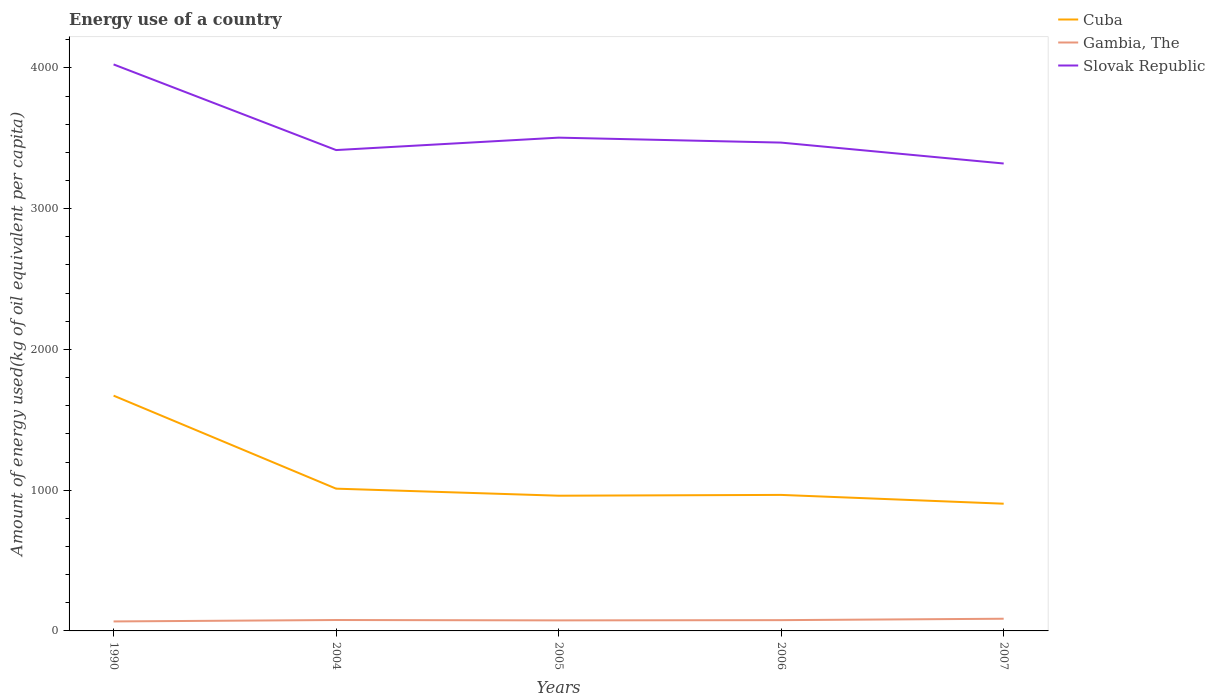How many different coloured lines are there?
Provide a succinct answer. 3. Across all years, what is the maximum amount of energy used in in Cuba?
Offer a terse response. 903.8. In which year was the amount of energy used in in Slovak Republic maximum?
Ensure brevity in your answer.  2007. What is the total amount of energy used in in Cuba in the graph?
Your answer should be very brief. 710.84. What is the difference between the highest and the second highest amount of energy used in in Gambia, The?
Offer a very short reply. 19.17. Is the amount of energy used in in Cuba strictly greater than the amount of energy used in in Gambia, The over the years?
Your answer should be compact. No. How many years are there in the graph?
Your response must be concise. 5. Are the values on the major ticks of Y-axis written in scientific E-notation?
Provide a short and direct response. No. Does the graph contain any zero values?
Ensure brevity in your answer.  No. How many legend labels are there?
Keep it short and to the point. 3. How are the legend labels stacked?
Offer a terse response. Vertical. What is the title of the graph?
Provide a succinct answer. Energy use of a country. Does "Palau" appear as one of the legend labels in the graph?
Keep it short and to the point. No. What is the label or title of the Y-axis?
Give a very brief answer. Amount of energy used(kg of oil equivalent per capita). What is the Amount of energy used(kg of oil equivalent per capita) in Cuba in 1990?
Provide a short and direct response. 1671.51. What is the Amount of energy used(kg of oil equivalent per capita) of Gambia, The in 1990?
Keep it short and to the point. 67.4. What is the Amount of energy used(kg of oil equivalent per capita) in Slovak Republic in 1990?
Provide a short and direct response. 4024.67. What is the Amount of energy used(kg of oil equivalent per capita) of Cuba in 2004?
Your answer should be very brief. 1010.68. What is the Amount of energy used(kg of oil equivalent per capita) of Gambia, The in 2004?
Your response must be concise. 77.43. What is the Amount of energy used(kg of oil equivalent per capita) of Slovak Republic in 2004?
Your answer should be very brief. 3416.25. What is the Amount of energy used(kg of oil equivalent per capita) in Cuba in 2005?
Your response must be concise. 960.67. What is the Amount of energy used(kg of oil equivalent per capita) of Gambia, The in 2005?
Your answer should be very brief. 74.97. What is the Amount of energy used(kg of oil equivalent per capita) of Slovak Republic in 2005?
Offer a very short reply. 3504.48. What is the Amount of energy used(kg of oil equivalent per capita) of Cuba in 2006?
Ensure brevity in your answer.  966.35. What is the Amount of energy used(kg of oil equivalent per capita) in Gambia, The in 2006?
Your answer should be very brief. 76.63. What is the Amount of energy used(kg of oil equivalent per capita) of Slovak Republic in 2006?
Ensure brevity in your answer.  3469.29. What is the Amount of energy used(kg of oil equivalent per capita) of Cuba in 2007?
Your answer should be compact. 903.8. What is the Amount of energy used(kg of oil equivalent per capita) in Gambia, The in 2007?
Ensure brevity in your answer.  86.56. What is the Amount of energy used(kg of oil equivalent per capita) of Slovak Republic in 2007?
Your response must be concise. 3320.76. Across all years, what is the maximum Amount of energy used(kg of oil equivalent per capita) in Cuba?
Ensure brevity in your answer.  1671.51. Across all years, what is the maximum Amount of energy used(kg of oil equivalent per capita) of Gambia, The?
Offer a very short reply. 86.56. Across all years, what is the maximum Amount of energy used(kg of oil equivalent per capita) of Slovak Republic?
Ensure brevity in your answer.  4024.67. Across all years, what is the minimum Amount of energy used(kg of oil equivalent per capita) of Cuba?
Your answer should be very brief. 903.8. Across all years, what is the minimum Amount of energy used(kg of oil equivalent per capita) in Gambia, The?
Your response must be concise. 67.4. Across all years, what is the minimum Amount of energy used(kg of oil equivalent per capita) in Slovak Republic?
Provide a short and direct response. 3320.76. What is the total Amount of energy used(kg of oil equivalent per capita) of Cuba in the graph?
Your answer should be very brief. 5513.01. What is the total Amount of energy used(kg of oil equivalent per capita) of Gambia, The in the graph?
Keep it short and to the point. 383. What is the total Amount of energy used(kg of oil equivalent per capita) in Slovak Republic in the graph?
Ensure brevity in your answer.  1.77e+04. What is the difference between the Amount of energy used(kg of oil equivalent per capita) in Cuba in 1990 and that in 2004?
Offer a terse response. 660.82. What is the difference between the Amount of energy used(kg of oil equivalent per capita) of Gambia, The in 1990 and that in 2004?
Your answer should be very brief. -10.04. What is the difference between the Amount of energy used(kg of oil equivalent per capita) of Slovak Republic in 1990 and that in 2004?
Provide a succinct answer. 608.42. What is the difference between the Amount of energy used(kg of oil equivalent per capita) in Cuba in 1990 and that in 2005?
Make the answer very short. 710.84. What is the difference between the Amount of energy used(kg of oil equivalent per capita) in Gambia, The in 1990 and that in 2005?
Provide a short and direct response. -7.57. What is the difference between the Amount of energy used(kg of oil equivalent per capita) of Slovak Republic in 1990 and that in 2005?
Ensure brevity in your answer.  520.19. What is the difference between the Amount of energy used(kg of oil equivalent per capita) of Cuba in 1990 and that in 2006?
Provide a succinct answer. 705.16. What is the difference between the Amount of energy used(kg of oil equivalent per capita) in Gambia, The in 1990 and that in 2006?
Offer a terse response. -9.23. What is the difference between the Amount of energy used(kg of oil equivalent per capita) in Slovak Republic in 1990 and that in 2006?
Offer a very short reply. 555.38. What is the difference between the Amount of energy used(kg of oil equivalent per capita) of Cuba in 1990 and that in 2007?
Make the answer very short. 767.71. What is the difference between the Amount of energy used(kg of oil equivalent per capita) of Gambia, The in 1990 and that in 2007?
Provide a short and direct response. -19.17. What is the difference between the Amount of energy used(kg of oil equivalent per capita) of Slovak Republic in 1990 and that in 2007?
Keep it short and to the point. 703.91. What is the difference between the Amount of energy used(kg of oil equivalent per capita) of Cuba in 2004 and that in 2005?
Offer a terse response. 50.02. What is the difference between the Amount of energy used(kg of oil equivalent per capita) in Gambia, The in 2004 and that in 2005?
Your answer should be very brief. 2.46. What is the difference between the Amount of energy used(kg of oil equivalent per capita) in Slovak Republic in 2004 and that in 2005?
Offer a very short reply. -88.23. What is the difference between the Amount of energy used(kg of oil equivalent per capita) in Cuba in 2004 and that in 2006?
Provide a short and direct response. 44.33. What is the difference between the Amount of energy used(kg of oil equivalent per capita) in Gambia, The in 2004 and that in 2006?
Your answer should be very brief. 0.81. What is the difference between the Amount of energy used(kg of oil equivalent per capita) in Slovak Republic in 2004 and that in 2006?
Your answer should be very brief. -53.04. What is the difference between the Amount of energy used(kg of oil equivalent per capita) of Cuba in 2004 and that in 2007?
Provide a short and direct response. 106.89. What is the difference between the Amount of energy used(kg of oil equivalent per capita) in Gambia, The in 2004 and that in 2007?
Provide a short and direct response. -9.13. What is the difference between the Amount of energy used(kg of oil equivalent per capita) in Slovak Republic in 2004 and that in 2007?
Offer a very short reply. 95.49. What is the difference between the Amount of energy used(kg of oil equivalent per capita) in Cuba in 2005 and that in 2006?
Your answer should be compact. -5.68. What is the difference between the Amount of energy used(kg of oil equivalent per capita) in Gambia, The in 2005 and that in 2006?
Ensure brevity in your answer.  -1.66. What is the difference between the Amount of energy used(kg of oil equivalent per capita) in Slovak Republic in 2005 and that in 2006?
Make the answer very short. 35.18. What is the difference between the Amount of energy used(kg of oil equivalent per capita) in Cuba in 2005 and that in 2007?
Provide a succinct answer. 56.87. What is the difference between the Amount of energy used(kg of oil equivalent per capita) in Gambia, The in 2005 and that in 2007?
Your response must be concise. -11.59. What is the difference between the Amount of energy used(kg of oil equivalent per capita) in Slovak Republic in 2005 and that in 2007?
Give a very brief answer. 183.72. What is the difference between the Amount of energy used(kg of oil equivalent per capita) of Cuba in 2006 and that in 2007?
Your response must be concise. 62.55. What is the difference between the Amount of energy used(kg of oil equivalent per capita) in Gambia, The in 2006 and that in 2007?
Give a very brief answer. -9.94. What is the difference between the Amount of energy used(kg of oil equivalent per capita) of Slovak Republic in 2006 and that in 2007?
Offer a very short reply. 148.53. What is the difference between the Amount of energy used(kg of oil equivalent per capita) of Cuba in 1990 and the Amount of energy used(kg of oil equivalent per capita) of Gambia, The in 2004?
Your answer should be compact. 1594.07. What is the difference between the Amount of energy used(kg of oil equivalent per capita) in Cuba in 1990 and the Amount of energy used(kg of oil equivalent per capita) in Slovak Republic in 2004?
Your answer should be compact. -1744.74. What is the difference between the Amount of energy used(kg of oil equivalent per capita) in Gambia, The in 1990 and the Amount of energy used(kg of oil equivalent per capita) in Slovak Republic in 2004?
Make the answer very short. -3348.85. What is the difference between the Amount of energy used(kg of oil equivalent per capita) of Cuba in 1990 and the Amount of energy used(kg of oil equivalent per capita) of Gambia, The in 2005?
Keep it short and to the point. 1596.54. What is the difference between the Amount of energy used(kg of oil equivalent per capita) in Cuba in 1990 and the Amount of energy used(kg of oil equivalent per capita) in Slovak Republic in 2005?
Keep it short and to the point. -1832.97. What is the difference between the Amount of energy used(kg of oil equivalent per capita) of Gambia, The in 1990 and the Amount of energy used(kg of oil equivalent per capita) of Slovak Republic in 2005?
Your answer should be very brief. -3437.08. What is the difference between the Amount of energy used(kg of oil equivalent per capita) of Cuba in 1990 and the Amount of energy used(kg of oil equivalent per capita) of Gambia, The in 2006?
Your answer should be compact. 1594.88. What is the difference between the Amount of energy used(kg of oil equivalent per capita) of Cuba in 1990 and the Amount of energy used(kg of oil equivalent per capita) of Slovak Republic in 2006?
Provide a short and direct response. -1797.78. What is the difference between the Amount of energy used(kg of oil equivalent per capita) of Gambia, The in 1990 and the Amount of energy used(kg of oil equivalent per capita) of Slovak Republic in 2006?
Your response must be concise. -3401.89. What is the difference between the Amount of energy used(kg of oil equivalent per capita) in Cuba in 1990 and the Amount of energy used(kg of oil equivalent per capita) in Gambia, The in 2007?
Provide a succinct answer. 1584.94. What is the difference between the Amount of energy used(kg of oil equivalent per capita) in Cuba in 1990 and the Amount of energy used(kg of oil equivalent per capita) in Slovak Republic in 2007?
Make the answer very short. -1649.25. What is the difference between the Amount of energy used(kg of oil equivalent per capita) of Gambia, The in 1990 and the Amount of energy used(kg of oil equivalent per capita) of Slovak Republic in 2007?
Give a very brief answer. -3253.36. What is the difference between the Amount of energy used(kg of oil equivalent per capita) in Cuba in 2004 and the Amount of energy used(kg of oil equivalent per capita) in Gambia, The in 2005?
Your answer should be very brief. 935.71. What is the difference between the Amount of energy used(kg of oil equivalent per capita) in Cuba in 2004 and the Amount of energy used(kg of oil equivalent per capita) in Slovak Republic in 2005?
Provide a succinct answer. -2493.79. What is the difference between the Amount of energy used(kg of oil equivalent per capita) of Gambia, The in 2004 and the Amount of energy used(kg of oil equivalent per capita) of Slovak Republic in 2005?
Keep it short and to the point. -3427.04. What is the difference between the Amount of energy used(kg of oil equivalent per capita) of Cuba in 2004 and the Amount of energy used(kg of oil equivalent per capita) of Gambia, The in 2006?
Provide a succinct answer. 934.06. What is the difference between the Amount of energy used(kg of oil equivalent per capita) in Cuba in 2004 and the Amount of energy used(kg of oil equivalent per capita) in Slovak Republic in 2006?
Ensure brevity in your answer.  -2458.61. What is the difference between the Amount of energy used(kg of oil equivalent per capita) of Gambia, The in 2004 and the Amount of energy used(kg of oil equivalent per capita) of Slovak Republic in 2006?
Offer a very short reply. -3391.86. What is the difference between the Amount of energy used(kg of oil equivalent per capita) of Cuba in 2004 and the Amount of energy used(kg of oil equivalent per capita) of Gambia, The in 2007?
Your response must be concise. 924.12. What is the difference between the Amount of energy used(kg of oil equivalent per capita) in Cuba in 2004 and the Amount of energy used(kg of oil equivalent per capita) in Slovak Republic in 2007?
Your answer should be very brief. -2310.07. What is the difference between the Amount of energy used(kg of oil equivalent per capita) in Gambia, The in 2004 and the Amount of energy used(kg of oil equivalent per capita) in Slovak Republic in 2007?
Give a very brief answer. -3243.32. What is the difference between the Amount of energy used(kg of oil equivalent per capita) of Cuba in 2005 and the Amount of energy used(kg of oil equivalent per capita) of Gambia, The in 2006?
Your answer should be very brief. 884.04. What is the difference between the Amount of energy used(kg of oil equivalent per capita) in Cuba in 2005 and the Amount of energy used(kg of oil equivalent per capita) in Slovak Republic in 2006?
Give a very brief answer. -2508.62. What is the difference between the Amount of energy used(kg of oil equivalent per capita) of Gambia, The in 2005 and the Amount of energy used(kg of oil equivalent per capita) of Slovak Republic in 2006?
Ensure brevity in your answer.  -3394.32. What is the difference between the Amount of energy used(kg of oil equivalent per capita) of Cuba in 2005 and the Amount of energy used(kg of oil equivalent per capita) of Gambia, The in 2007?
Offer a very short reply. 874.1. What is the difference between the Amount of energy used(kg of oil equivalent per capita) of Cuba in 2005 and the Amount of energy used(kg of oil equivalent per capita) of Slovak Republic in 2007?
Offer a very short reply. -2360.09. What is the difference between the Amount of energy used(kg of oil equivalent per capita) of Gambia, The in 2005 and the Amount of energy used(kg of oil equivalent per capita) of Slovak Republic in 2007?
Provide a succinct answer. -3245.79. What is the difference between the Amount of energy used(kg of oil equivalent per capita) of Cuba in 2006 and the Amount of energy used(kg of oil equivalent per capita) of Gambia, The in 2007?
Offer a terse response. 879.79. What is the difference between the Amount of energy used(kg of oil equivalent per capita) in Cuba in 2006 and the Amount of energy used(kg of oil equivalent per capita) in Slovak Republic in 2007?
Your response must be concise. -2354.41. What is the difference between the Amount of energy used(kg of oil equivalent per capita) in Gambia, The in 2006 and the Amount of energy used(kg of oil equivalent per capita) in Slovak Republic in 2007?
Your answer should be very brief. -3244.13. What is the average Amount of energy used(kg of oil equivalent per capita) in Cuba per year?
Your answer should be compact. 1102.6. What is the average Amount of energy used(kg of oil equivalent per capita) of Gambia, The per year?
Your answer should be compact. 76.6. What is the average Amount of energy used(kg of oil equivalent per capita) of Slovak Republic per year?
Provide a succinct answer. 3547.09. In the year 1990, what is the difference between the Amount of energy used(kg of oil equivalent per capita) in Cuba and Amount of energy used(kg of oil equivalent per capita) in Gambia, The?
Make the answer very short. 1604.11. In the year 1990, what is the difference between the Amount of energy used(kg of oil equivalent per capita) of Cuba and Amount of energy used(kg of oil equivalent per capita) of Slovak Republic?
Give a very brief answer. -2353.16. In the year 1990, what is the difference between the Amount of energy used(kg of oil equivalent per capita) of Gambia, The and Amount of energy used(kg of oil equivalent per capita) of Slovak Republic?
Offer a very short reply. -3957.27. In the year 2004, what is the difference between the Amount of energy used(kg of oil equivalent per capita) of Cuba and Amount of energy used(kg of oil equivalent per capita) of Gambia, The?
Keep it short and to the point. 933.25. In the year 2004, what is the difference between the Amount of energy used(kg of oil equivalent per capita) in Cuba and Amount of energy used(kg of oil equivalent per capita) in Slovak Republic?
Your response must be concise. -2405.56. In the year 2004, what is the difference between the Amount of energy used(kg of oil equivalent per capita) in Gambia, The and Amount of energy used(kg of oil equivalent per capita) in Slovak Republic?
Your response must be concise. -3338.81. In the year 2005, what is the difference between the Amount of energy used(kg of oil equivalent per capita) of Cuba and Amount of energy used(kg of oil equivalent per capita) of Gambia, The?
Your response must be concise. 885.7. In the year 2005, what is the difference between the Amount of energy used(kg of oil equivalent per capita) of Cuba and Amount of energy used(kg of oil equivalent per capita) of Slovak Republic?
Give a very brief answer. -2543.81. In the year 2005, what is the difference between the Amount of energy used(kg of oil equivalent per capita) in Gambia, The and Amount of energy used(kg of oil equivalent per capita) in Slovak Republic?
Make the answer very short. -3429.5. In the year 2006, what is the difference between the Amount of energy used(kg of oil equivalent per capita) in Cuba and Amount of energy used(kg of oil equivalent per capita) in Gambia, The?
Give a very brief answer. 889.72. In the year 2006, what is the difference between the Amount of energy used(kg of oil equivalent per capita) in Cuba and Amount of energy used(kg of oil equivalent per capita) in Slovak Republic?
Your answer should be very brief. -2502.94. In the year 2006, what is the difference between the Amount of energy used(kg of oil equivalent per capita) in Gambia, The and Amount of energy used(kg of oil equivalent per capita) in Slovak Republic?
Ensure brevity in your answer.  -3392.66. In the year 2007, what is the difference between the Amount of energy used(kg of oil equivalent per capita) of Cuba and Amount of energy used(kg of oil equivalent per capita) of Gambia, The?
Keep it short and to the point. 817.23. In the year 2007, what is the difference between the Amount of energy used(kg of oil equivalent per capita) of Cuba and Amount of energy used(kg of oil equivalent per capita) of Slovak Republic?
Your answer should be compact. -2416.96. In the year 2007, what is the difference between the Amount of energy used(kg of oil equivalent per capita) of Gambia, The and Amount of energy used(kg of oil equivalent per capita) of Slovak Republic?
Your answer should be compact. -3234.19. What is the ratio of the Amount of energy used(kg of oil equivalent per capita) of Cuba in 1990 to that in 2004?
Ensure brevity in your answer.  1.65. What is the ratio of the Amount of energy used(kg of oil equivalent per capita) in Gambia, The in 1990 to that in 2004?
Your answer should be compact. 0.87. What is the ratio of the Amount of energy used(kg of oil equivalent per capita) in Slovak Republic in 1990 to that in 2004?
Your answer should be compact. 1.18. What is the ratio of the Amount of energy used(kg of oil equivalent per capita) of Cuba in 1990 to that in 2005?
Your response must be concise. 1.74. What is the ratio of the Amount of energy used(kg of oil equivalent per capita) in Gambia, The in 1990 to that in 2005?
Provide a short and direct response. 0.9. What is the ratio of the Amount of energy used(kg of oil equivalent per capita) of Slovak Republic in 1990 to that in 2005?
Your answer should be very brief. 1.15. What is the ratio of the Amount of energy used(kg of oil equivalent per capita) in Cuba in 1990 to that in 2006?
Your answer should be compact. 1.73. What is the ratio of the Amount of energy used(kg of oil equivalent per capita) in Gambia, The in 1990 to that in 2006?
Keep it short and to the point. 0.88. What is the ratio of the Amount of energy used(kg of oil equivalent per capita) in Slovak Republic in 1990 to that in 2006?
Provide a succinct answer. 1.16. What is the ratio of the Amount of energy used(kg of oil equivalent per capita) in Cuba in 1990 to that in 2007?
Ensure brevity in your answer.  1.85. What is the ratio of the Amount of energy used(kg of oil equivalent per capita) in Gambia, The in 1990 to that in 2007?
Ensure brevity in your answer.  0.78. What is the ratio of the Amount of energy used(kg of oil equivalent per capita) in Slovak Republic in 1990 to that in 2007?
Offer a terse response. 1.21. What is the ratio of the Amount of energy used(kg of oil equivalent per capita) in Cuba in 2004 to that in 2005?
Make the answer very short. 1.05. What is the ratio of the Amount of energy used(kg of oil equivalent per capita) in Gambia, The in 2004 to that in 2005?
Offer a terse response. 1.03. What is the ratio of the Amount of energy used(kg of oil equivalent per capita) in Slovak Republic in 2004 to that in 2005?
Your answer should be compact. 0.97. What is the ratio of the Amount of energy used(kg of oil equivalent per capita) of Cuba in 2004 to that in 2006?
Make the answer very short. 1.05. What is the ratio of the Amount of energy used(kg of oil equivalent per capita) in Gambia, The in 2004 to that in 2006?
Your response must be concise. 1.01. What is the ratio of the Amount of energy used(kg of oil equivalent per capita) of Slovak Republic in 2004 to that in 2006?
Your answer should be compact. 0.98. What is the ratio of the Amount of energy used(kg of oil equivalent per capita) of Cuba in 2004 to that in 2007?
Ensure brevity in your answer.  1.12. What is the ratio of the Amount of energy used(kg of oil equivalent per capita) of Gambia, The in 2004 to that in 2007?
Keep it short and to the point. 0.89. What is the ratio of the Amount of energy used(kg of oil equivalent per capita) of Slovak Republic in 2004 to that in 2007?
Give a very brief answer. 1.03. What is the ratio of the Amount of energy used(kg of oil equivalent per capita) of Gambia, The in 2005 to that in 2006?
Ensure brevity in your answer.  0.98. What is the ratio of the Amount of energy used(kg of oil equivalent per capita) of Cuba in 2005 to that in 2007?
Provide a short and direct response. 1.06. What is the ratio of the Amount of energy used(kg of oil equivalent per capita) in Gambia, The in 2005 to that in 2007?
Make the answer very short. 0.87. What is the ratio of the Amount of energy used(kg of oil equivalent per capita) in Slovak Republic in 2005 to that in 2007?
Provide a succinct answer. 1.06. What is the ratio of the Amount of energy used(kg of oil equivalent per capita) in Cuba in 2006 to that in 2007?
Make the answer very short. 1.07. What is the ratio of the Amount of energy used(kg of oil equivalent per capita) in Gambia, The in 2006 to that in 2007?
Your response must be concise. 0.89. What is the ratio of the Amount of energy used(kg of oil equivalent per capita) in Slovak Republic in 2006 to that in 2007?
Offer a very short reply. 1.04. What is the difference between the highest and the second highest Amount of energy used(kg of oil equivalent per capita) in Cuba?
Provide a succinct answer. 660.82. What is the difference between the highest and the second highest Amount of energy used(kg of oil equivalent per capita) of Gambia, The?
Your answer should be very brief. 9.13. What is the difference between the highest and the second highest Amount of energy used(kg of oil equivalent per capita) in Slovak Republic?
Offer a terse response. 520.19. What is the difference between the highest and the lowest Amount of energy used(kg of oil equivalent per capita) in Cuba?
Make the answer very short. 767.71. What is the difference between the highest and the lowest Amount of energy used(kg of oil equivalent per capita) in Gambia, The?
Your answer should be very brief. 19.17. What is the difference between the highest and the lowest Amount of energy used(kg of oil equivalent per capita) in Slovak Republic?
Your response must be concise. 703.91. 